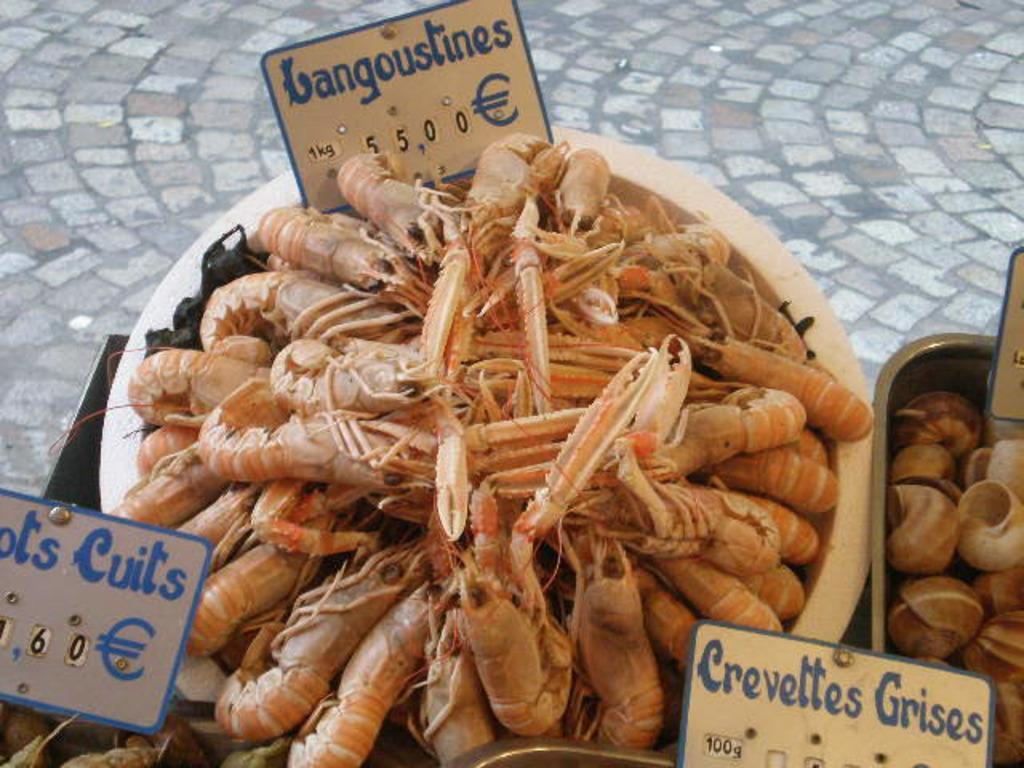How would you summarize this image in a sentence or two? There are dry shrimps, cells of snails and other objects arranged in the bowls along with the cards on the table, near a floor. 